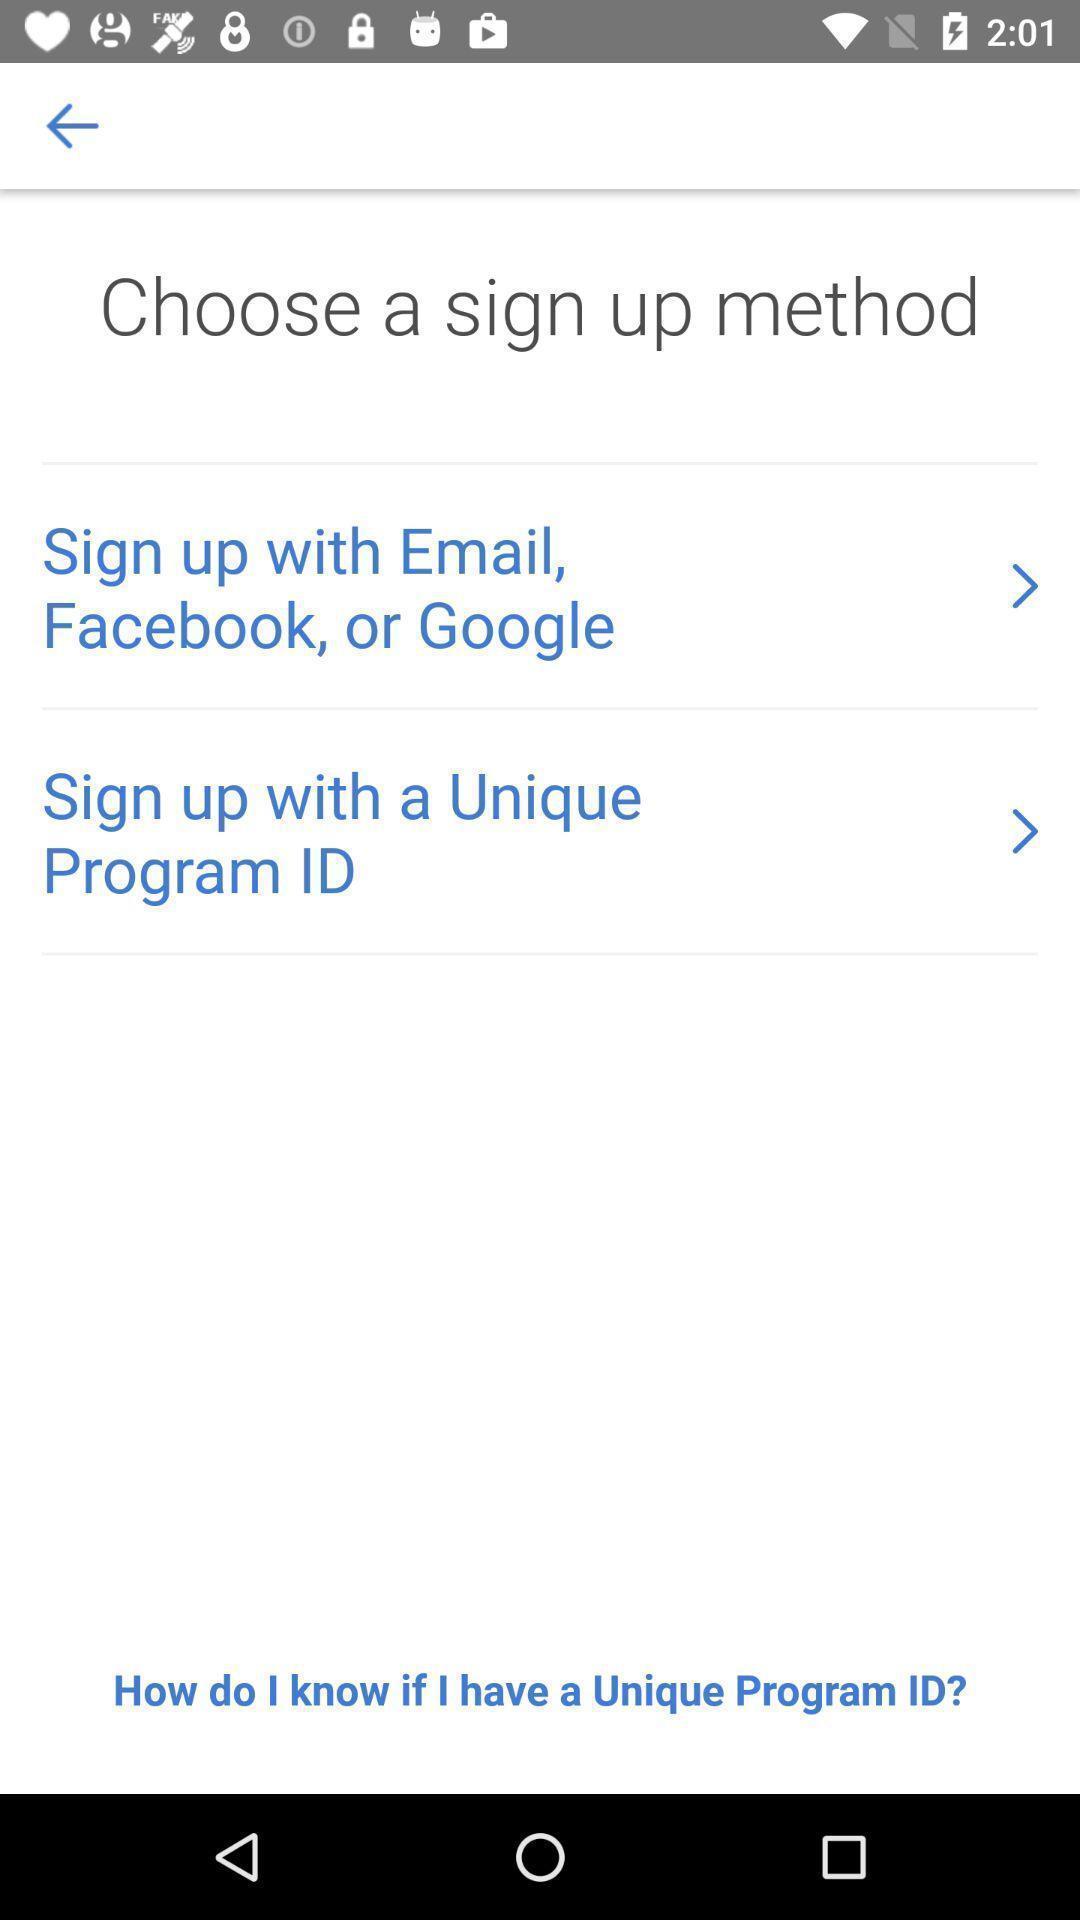Tell me what you see in this picture. Welcome page displaying login details. 